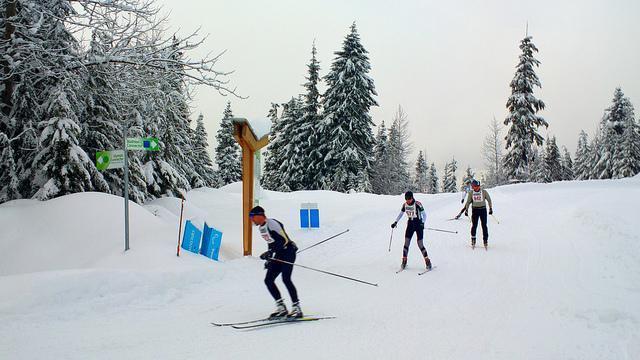Where was modern skiing invented?
Choose the correct response and explain in the format: 'Answer: answer
Rationale: rationale.'
Options: Switzerland, russia, china, scandinavia. Answer: scandinavia.
Rationale: Scandinavia is credited for skiing. 